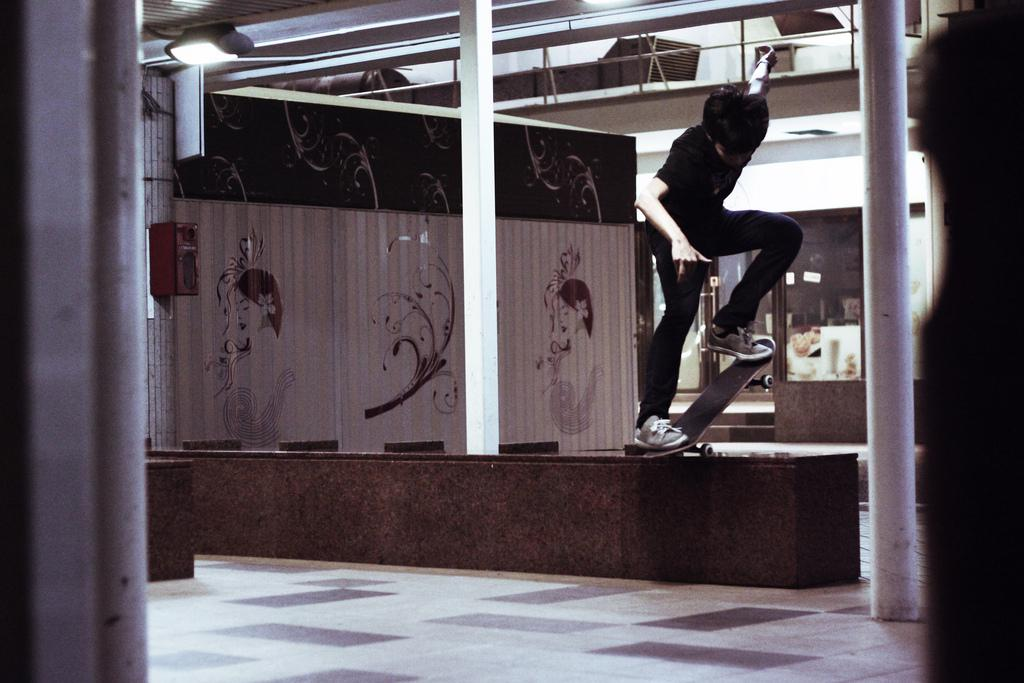Question: what is the boy doing?
Choices:
A. Skating.
B. Skateboarding.
C. Passing the officers.
D. Tricks on his skateboard.
Answer with the letter. Answer: B Question: how is the boy keeping balance?
Choices:
A. With his arms.
B. With his legs.
C. By looking forward.
D. By not moving.
Answer with the letter. Answer: A Question: what color shirt is the boy wearing?
Choices:
A. Red.
B. Black.
C. Green.
D. Yellow.
Answer with the letter. Answer: B Question: when is this photo taken?
Choices:
A. Night.
B. Day.
C. Morning.
D. Afternoon.
Answer with the letter. Answer: B Question: who is on the skateboard?
Choices:
A. A dog.
B. A lady.
C. A boy.
D. A cat.
Answer with the letter. Answer: C Question: why is the boy skateboarding indoors?
Choices:
A. It is where the ramps are.
B. There is no place outside to do it.
C. Perfect environment.
D. Because it is too cold outside.
Answer with the letter. Answer: C Question: what color is the boy's clothing?
Choices:
A. Red.
B. Yellow.
C. Green.
D. Black.
Answer with the letter. Answer: D Question: where are the dark and light patterned tiles?
Choices:
A. The floor.
B. On the sidewalk.
C. On the wall.
D. In the bathroom.
Answer with the letter. Answer: A Question: how are the boy's arms positioned?
Choices:
A. They are crossed.
B. Both are raised.
C. The right arm points down, the left arm is up.
D. Across his desk.
Answer with the letter. Answer: C Question: who is dressed in black?
Choices:
A. The policeman.
B. The fireman.
C. The boy.
D. The teacher.
Answer with the letter. Answer: C Question: where are the lights?
Choices:
A. On the wall.
B. On the floor.
C. On the stairs.
D. On ceiling.
Answer with the letter. Answer: D Question: where are the designs painted?
Choices:
A. On the china.
B. The back wall.
C. On the parchment.
D. On the sidewalk.
Answer with the letter. Answer: B Question: how many colors does the floor have?
Choices:
A. 5.
B. 3.
C. 1.
D. 2.
Answer with the letter. Answer: D Question: who has dark hair?
Choices:
A. The horse.
B. The woman and her daughter.
C. The boy.
D. The man with red glasses.
Answer with the letter. Answer: C Question: how are the guy's arms?
Choices:
A. Down.
B. In the air.
C. Around his wife.
D. Held out.
Answer with the letter. Answer: D 